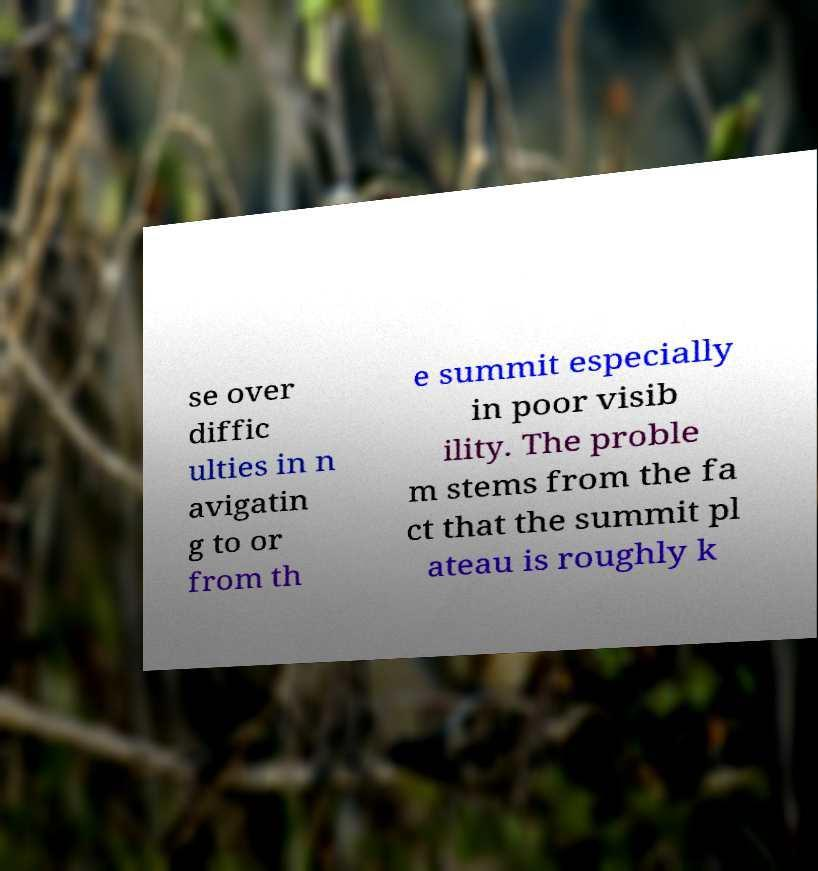Please read and relay the text visible in this image. What does it say? se over diffic ulties in n avigatin g to or from th e summit especially in poor visib ility. The proble m stems from the fa ct that the summit pl ateau is roughly k 